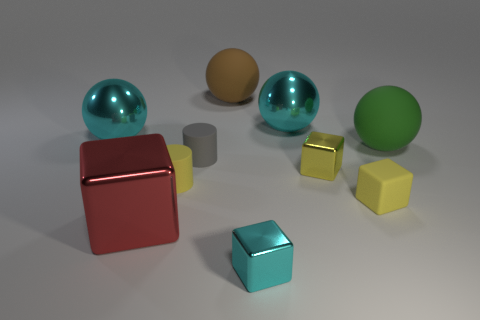Subtract 1 balls. How many balls are left? 3 Subtract all cylinders. How many objects are left? 8 Subtract all tiny shiny objects. Subtract all large objects. How many objects are left? 3 Add 5 small yellow rubber objects. How many small yellow rubber objects are left? 7 Add 3 large red shiny balls. How many large red shiny balls exist? 3 Subtract 0 green cubes. How many objects are left? 10 